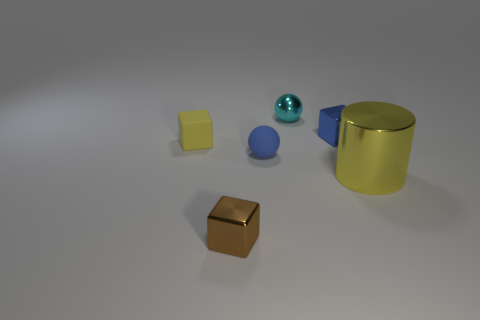Add 1 big cyan cylinders. How many objects exist? 7 Subtract all brown balls. Subtract all purple cylinders. How many balls are left? 2 Subtract all balls. How many objects are left? 4 Add 1 shiny cylinders. How many shiny cylinders are left? 2 Add 3 matte balls. How many matte balls exist? 4 Subtract 0 purple cylinders. How many objects are left? 6 Subtract all tiny blue objects. Subtract all small blue metal blocks. How many objects are left? 3 